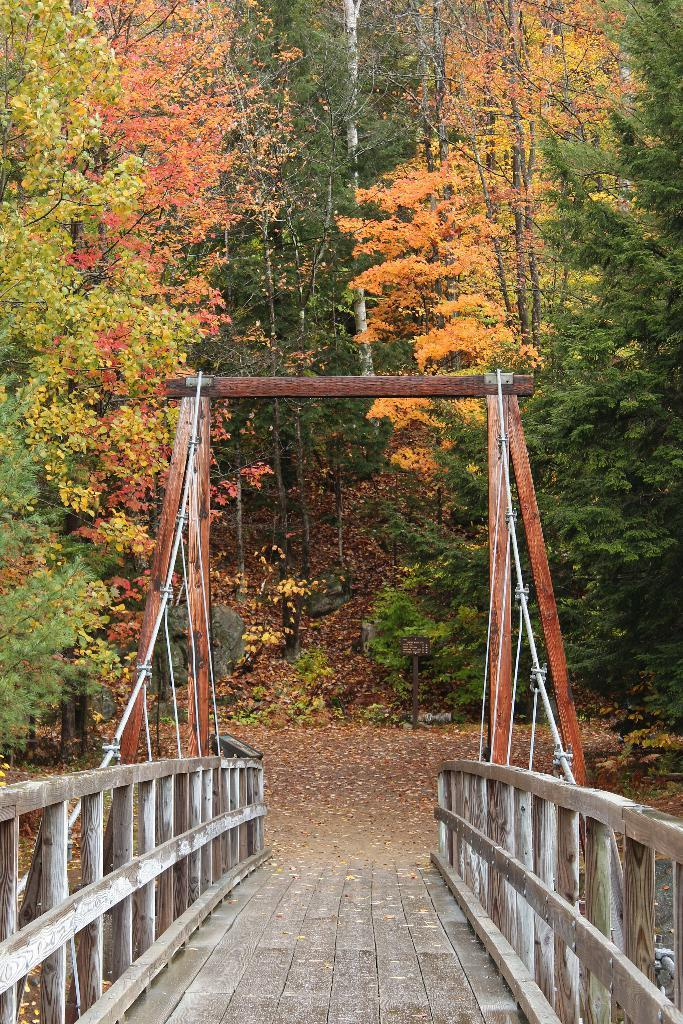What type of structure is present in the image? There is a wooden bridge in the image. What is located near the bridge? There is a wooden pole near the bridge. What type of vegetation can be seen in the image? There are trees visible in the image. What type of natural feature is present in the image? There are rocks in the image. What type of terrain is visible in the image? There is land visible in the image. What is the taste of the wooden bridge in the image? The wooden bridge does not have a taste, as it is a structure made of wood. 